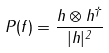<formula> <loc_0><loc_0><loc_500><loc_500>P ( f ) = \frac { h \otimes h ^ { \dagger } } { | h | ^ { 2 } }</formula> 